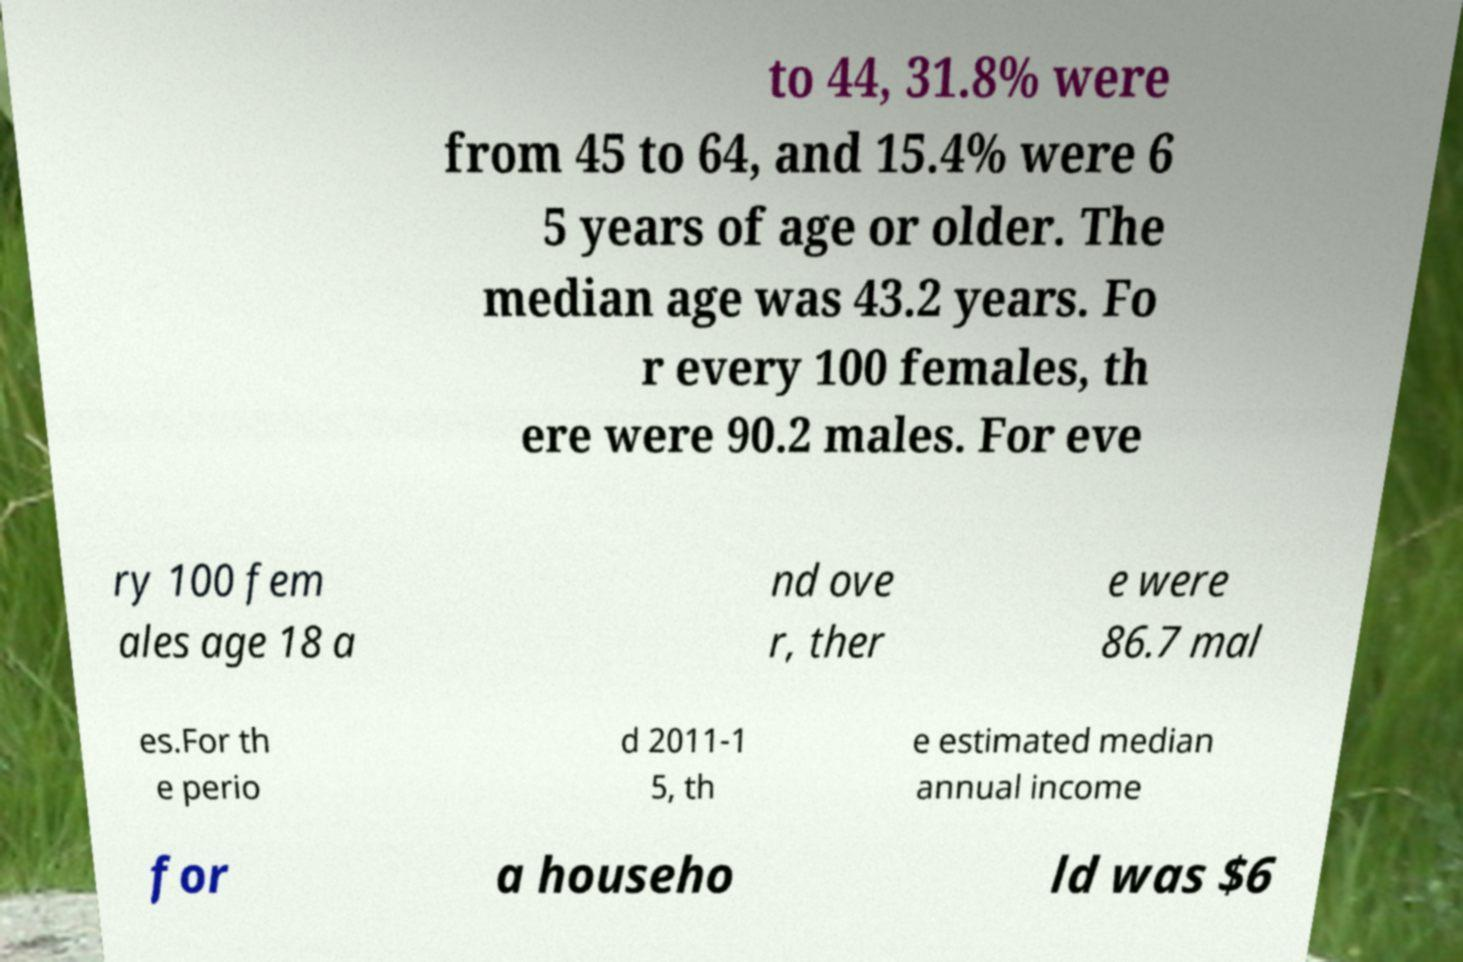I need the written content from this picture converted into text. Can you do that? to 44, 31.8% were from 45 to 64, and 15.4% were 6 5 years of age or older. The median age was 43.2 years. Fo r every 100 females, th ere were 90.2 males. For eve ry 100 fem ales age 18 a nd ove r, ther e were 86.7 mal es.For th e perio d 2011-1 5, th e estimated median annual income for a househo ld was $6 